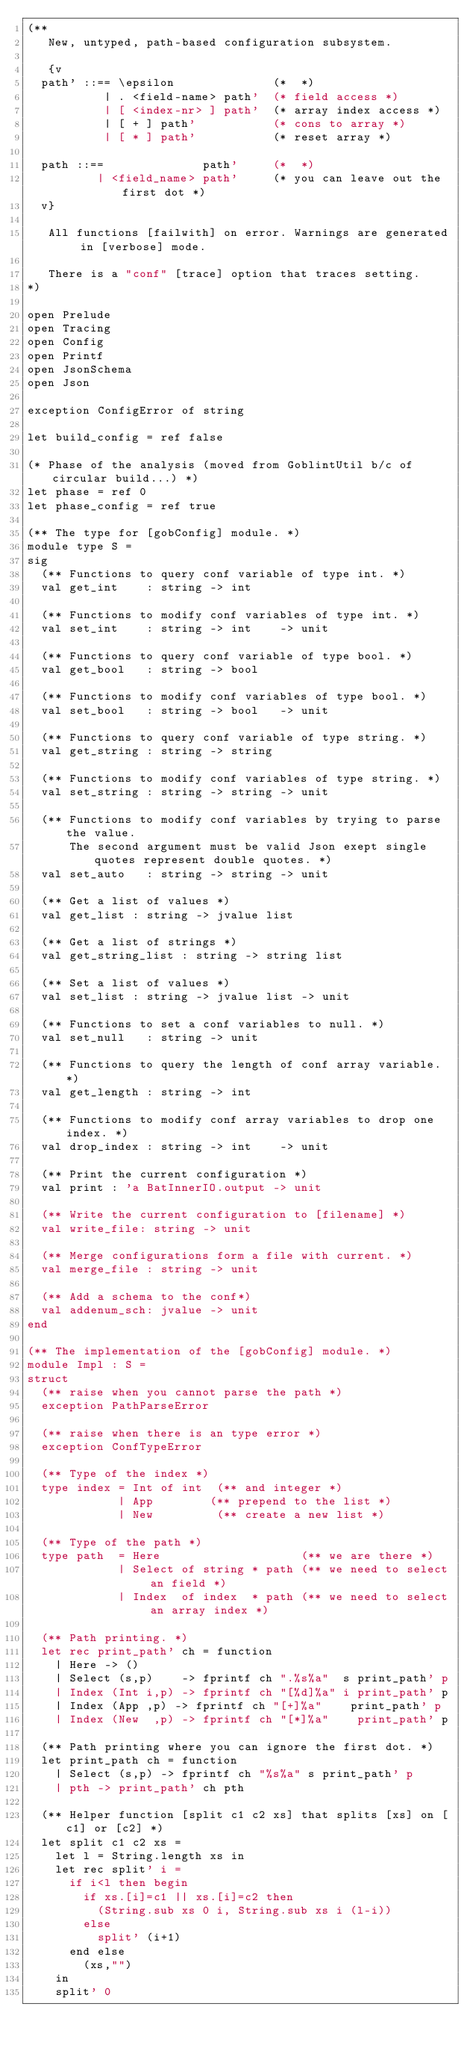Convert code to text. <code><loc_0><loc_0><loc_500><loc_500><_OCaml_>(**
   New, untyped, path-based configuration subsystem.

   {v
  path' ::== \epsilon              (*  *)
           | . <field-name> path'  (* field access *)
           | [ <index-nr> ] path'  (* array index access *)
           | [ + ] path'           (* cons to array *)
           | [ * ] path'           (* reset array *)

  path ::==              path'     (*  *)
          | <field_name> path'     (* you can leave out the first dot *)
  v}

   All functions [failwith] on error. Warnings are generated in [verbose] mode.

   There is a "conf" [trace] option that traces setting.
*)

open Prelude
open Tracing
open Config
open Printf
open JsonSchema
open Json

exception ConfigError of string

let build_config = ref false

(* Phase of the analysis (moved from GoblintUtil b/c of circular build...) *)
let phase = ref 0
let phase_config = ref true

(** The type for [gobConfig] module. *)
module type S =
sig
  (** Functions to query conf variable of type int. *)
  val get_int    : string -> int

  (** Functions to modify conf variables of type int. *)
  val set_int    : string -> int    -> unit

  (** Functions to query conf variable of type bool. *)
  val get_bool   : string -> bool

  (** Functions to modify conf variables of type bool. *)
  val set_bool   : string -> bool   -> unit

  (** Functions to query conf variable of type string. *)
  val get_string : string -> string

  (** Functions to modify conf variables of type string. *)
  val set_string : string -> string -> unit

  (** Functions to modify conf variables by trying to parse the value.
      The second argument must be valid Json exept single quotes represent double quotes. *)
  val set_auto   : string -> string -> unit

  (** Get a list of values *)
  val get_list : string -> jvalue list

  (** Get a list of strings *)
  val get_string_list : string -> string list

  (** Set a list of values *)
  val set_list : string -> jvalue list -> unit

  (** Functions to set a conf variables to null. *)
  val set_null   : string -> unit

  (** Functions to query the length of conf array variable. *)
  val get_length : string -> int

  (** Functions to modify conf array variables to drop one index. *)
  val drop_index : string -> int    -> unit

  (** Print the current configuration *)
  val print : 'a BatInnerIO.output -> unit

  (** Write the current configuration to [filename] *)
  val write_file: string -> unit

  (** Merge configurations form a file with current. *)
  val merge_file : string -> unit

  (** Add a schema to the conf*)
  val addenum_sch: jvalue -> unit
end

(** The implementation of the [gobConfig] module. *)
module Impl : S =
struct
  (** raise when you cannot parse the path *)
  exception PathParseError

  (** raise when there is an type error *)
  exception ConfTypeError

  (** Type of the index *)
  type index = Int of int  (** and integer *)
             | App        (** prepend to the list *)
             | New         (** create a new list *)

  (** Type of the path *)
  type path  = Here                    (** we are there *)
             | Select of string * path (** we need to select an field *)
             | Index  of index  * path (** we need to select an array index *)

  (** Path printing. *)
  let rec print_path' ch = function
    | Here -> ()
    | Select (s,p)    -> fprintf ch ".%s%a"  s print_path' p
    | Index (Int i,p) -> fprintf ch "[%d]%a" i print_path' p
    | Index (App ,p) -> fprintf ch "[+]%a"    print_path' p
    | Index (New  ,p) -> fprintf ch "[*]%a"    print_path' p

  (** Path printing where you can ignore the first dot. *)
  let print_path ch = function
    | Select (s,p) -> fprintf ch "%s%a" s print_path' p
    | pth -> print_path' ch pth

  (** Helper function [split c1 c2 xs] that splits [xs] on [c1] or [c2] *)
  let split c1 c2 xs =
    let l = String.length xs in
    let rec split' i =
      if i<l then begin
        if xs.[i]=c1 || xs.[i]=c2 then
          (String.sub xs 0 i, String.sub xs i (l-i))
        else
          split' (i+1)
      end else
        (xs,"")
    in
    split' 0
</code> 